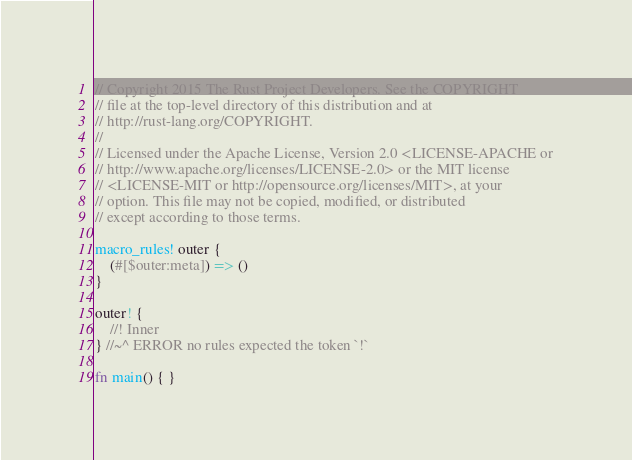Convert code to text. <code><loc_0><loc_0><loc_500><loc_500><_Rust_>// Copyright 2015 The Rust Project Developers. See the COPYRIGHT
// file at the top-level directory of this distribution and at
// http://rust-lang.org/COPYRIGHT.
//
// Licensed under the Apache License, Version 2.0 <LICENSE-APACHE or
// http://www.apache.org/licenses/LICENSE-2.0> or the MIT license
// <LICENSE-MIT or http://opensource.org/licenses/MIT>, at your
// option. This file may not be copied, modified, or distributed
// except according to those terms.

macro_rules! outer {
    (#[$outer:meta]) => ()
}

outer! {
    //! Inner
} //~^ ERROR no rules expected the token `!`

fn main() { }
</code> 